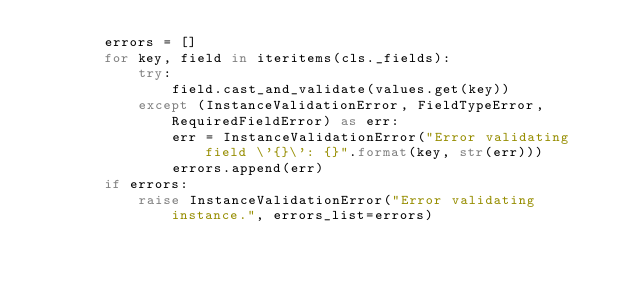Convert code to text. <code><loc_0><loc_0><loc_500><loc_500><_Python_>        errors = []
        for key, field in iteritems(cls._fields):
            try:
                field.cast_and_validate(values.get(key))
            except (InstanceValidationError, FieldTypeError, RequiredFieldError) as err:
                err = InstanceValidationError("Error validating field \'{}\': {}".format(key, str(err)))
                errors.append(err)
        if errors:
            raise InstanceValidationError("Error validating instance.", errors_list=errors)
</code> 